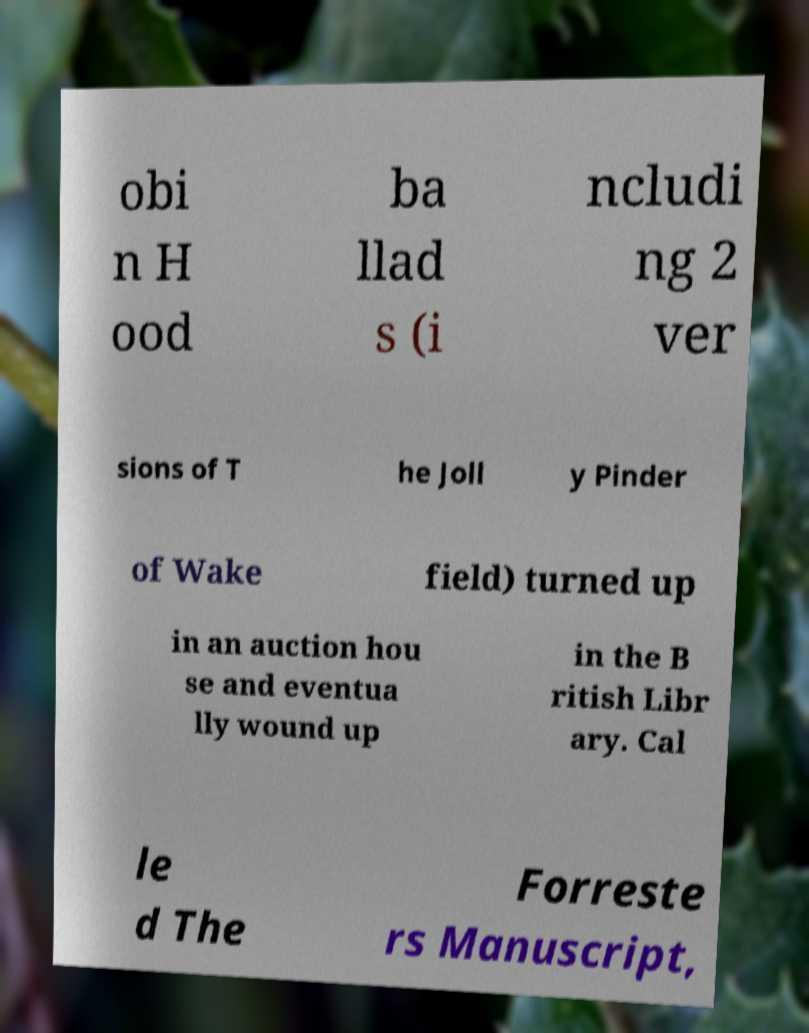Could you extract and type out the text from this image? obi n H ood ba llad s (i ncludi ng 2 ver sions of T he Joll y Pinder of Wake field) turned up in an auction hou se and eventua lly wound up in the B ritish Libr ary. Cal le d The Forreste rs Manuscript, 